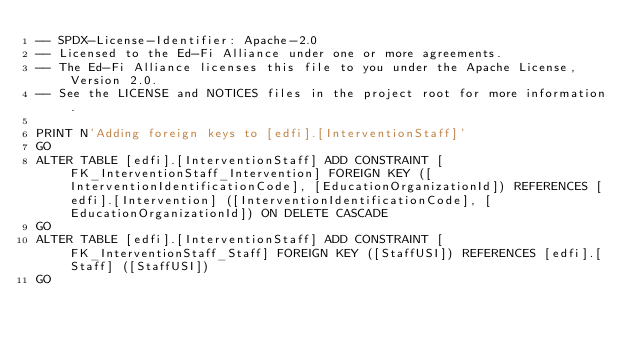<code> <loc_0><loc_0><loc_500><loc_500><_SQL_>-- SPDX-License-Identifier: Apache-2.0
-- Licensed to the Ed-Fi Alliance under one or more agreements.
-- The Ed-Fi Alliance licenses this file to you under the Apache License, Version 2.0.
-- See the LICENSE and NOTICES files in the project root for more information.

PRINT N'Adding foreign keys to [edfi].[InterventionStaff]'
GO
ALTER TABLE [edfi].[InterventionStaff] ADD CONSTRAINT [FK_InterventionStaff_Intervention] FOREIGN KEY ([InterventionIdentificationCode], [EducationOrganizationId]) REFERENCES [edfi].[Intervention] ([InterventionIdentificationCode], [EducationOrganizationId]) ON DELETE CASCADE
GO
ALTER TABLE [edfi].[InterventionStaff] ADD CONSTRAINT [FK_InterventionStaff_Staff] FOREIGN KEY ([StaffUSI]) REFERENCES [edfi].[Staff] ([StaffUSI])
GO
</code> 